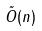Convert formula to latex. <formula><loc_0><loc_0><loc_500><loc_500>\tilde { O } ( n )</formula> 